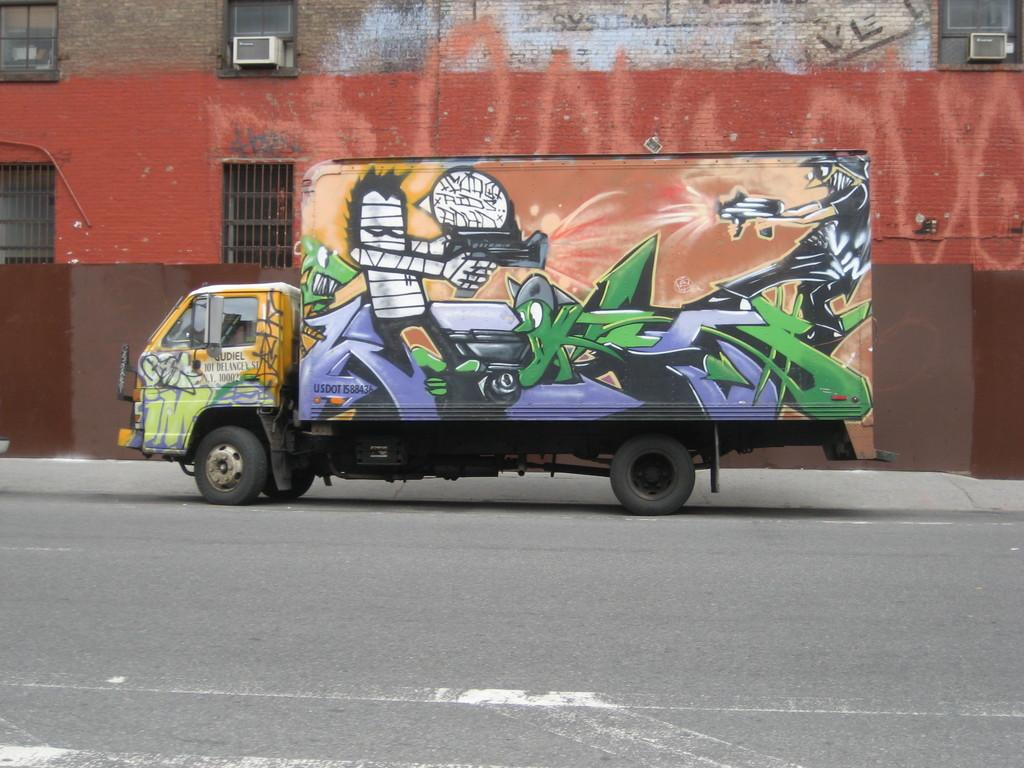What is the main subject of the image? There is a vehicle on the road in the image. Where is the vehicle located in the image? The vehicle is in the center of the image. What can be seen in the background of the image? There is a building in the background of the image. What features are visible on the building? There are air conditioners and windows visible on the building. Reasoning: Let's think step by step by step in order to produce the conversation. We start by identifying the main subject of the image, which is the vehicle on the road. Then, we describe the location of the vehicle within the image. Next, we shift our focus to the background of the image, noting the presence of a building. Finally, we provide details about the features of the building, including air conditioners and windows. Absurd Question/Answer: What type of writing can be seen on the vehicle's mouth in the image? There is no writing on the vehicle's mouth in the image, as vehicles do not have mouths. 